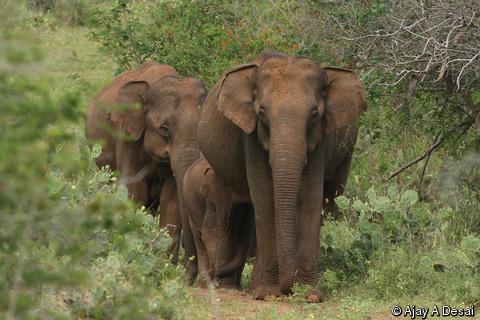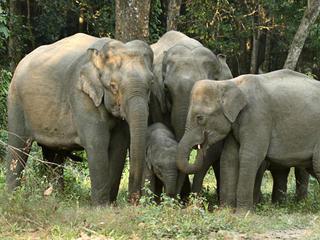The first image is the image on the left, the second image is the image on the right. Considering the images on both sides, is "There are two elephants in total." valid? Answer yes or no. No. 